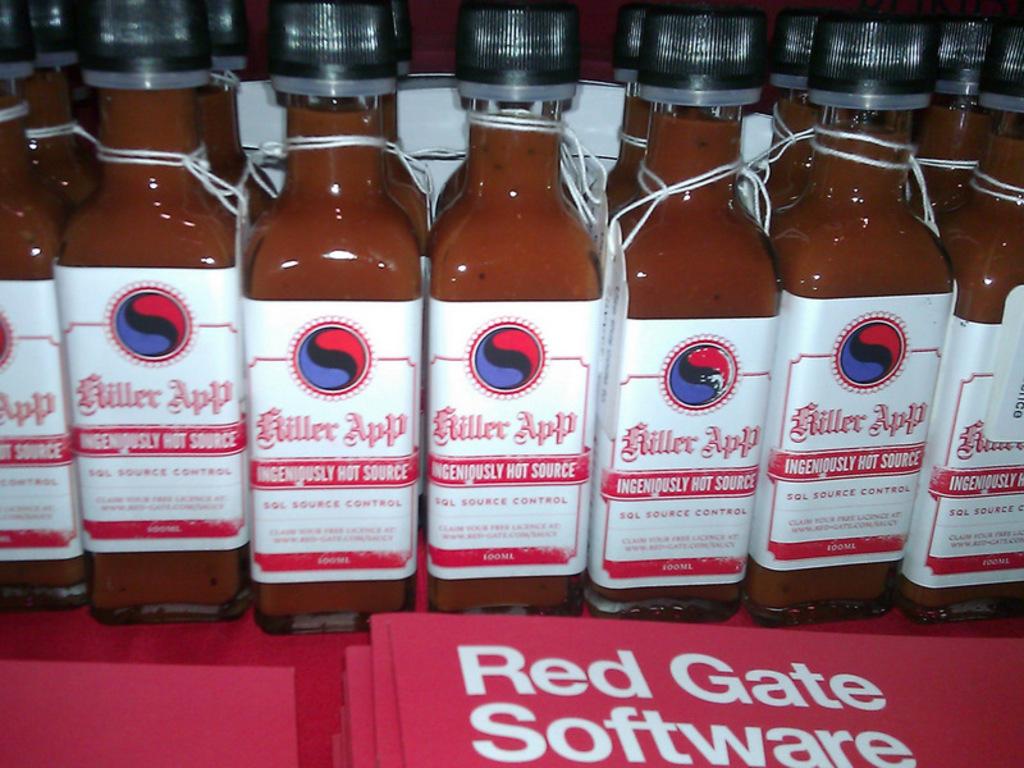What brand is the sauce being feature?
Your answer should be compact. Killer app. What words are written on the red folder?
Offer a terse response. Red gate software. 